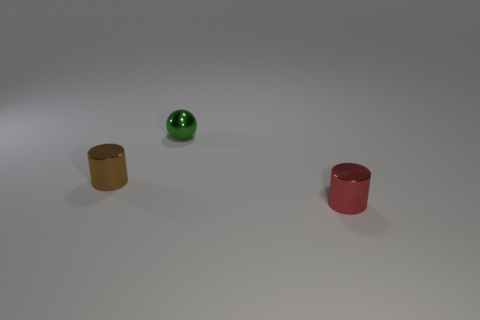Add 3 brown objects. How many objects exist? 6 Subtract all balls. How many objects are left? 2 Add 1 red cylinders. How many red cylinders exist? 2 Subtract 0 red balls. How many objects are left? 3 Subtract all purple rubber cylinders. Subtract all shiny cylinders. How many objects are left? 1 Add 2 green metallic things. How many green metallic things are left? 3 